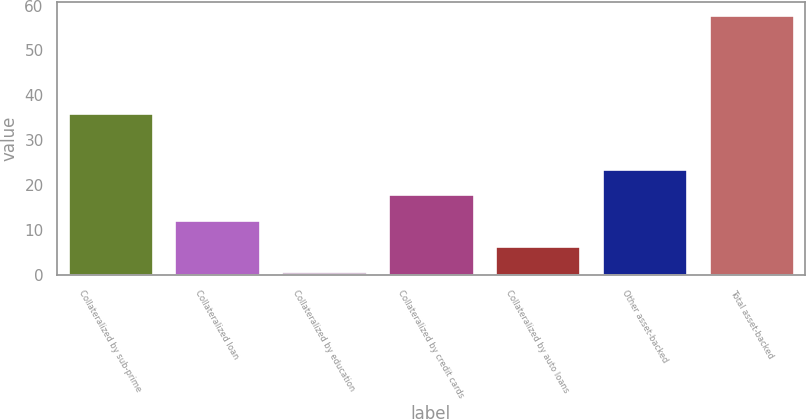Convert chart to OTSL. <chart><loc_0><loc_0><loc_500><loc_500><bar_chart><fcel>Collateralized by sub-prime<fcel>Collateralized loan<fcel>Collateralized by education<fcel>Collateralized by credit cards<fcel>Collateralized by auto loans<fcel>Other asset-backed<fcel>Total asset-backed<nl><fcel>36<fcel>12.25<fcel>0.81<fcel>17.97<fcel>6.53<fcel>23.69<fcel>58<nl></chart> 